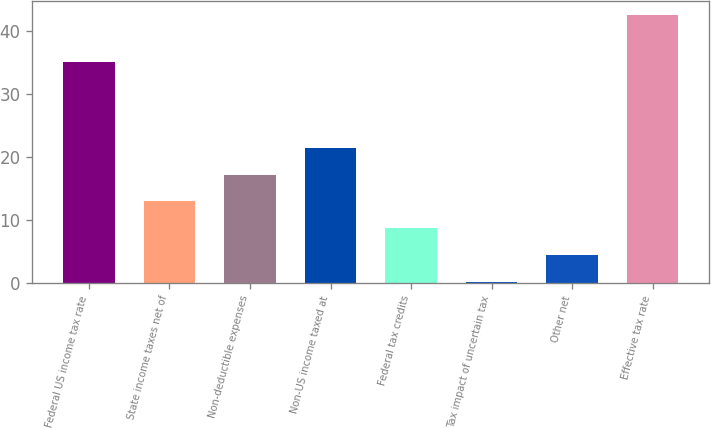Convert chart. <chart><loc_0><loc_0><loc_500><loc_500><bar_chart><fcel>Federal US income tax rate<fcel>State income taxes net of<fcel>Non-deductible expenses<fcel>Non-US income taxed at<fcel>Federal tax credits<fcel>Tax impact of uncertain tax<fcel>Other net<fcel>Effective tax rate<nl><fcel>35<fcel>12.92<fcel>17.16<fcel>21.4<fcel>8.68<fcel>0.2<fcel>4.44<fcel>42.6<nl></chart> 